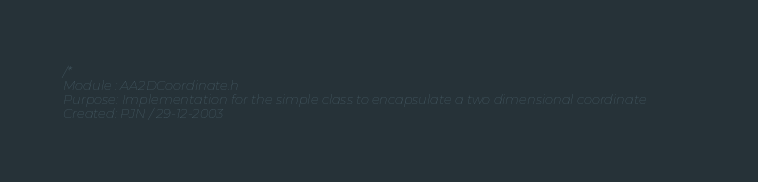<code> <loc_0><loc_0><loc_500><loc_500><_C_>/*
Module : AA2DCoordinate.h
Purpose: Implementation for the simple class to encapsulate a two dimensional coordinate
Created: PJN / 29-12-2003
</code> 